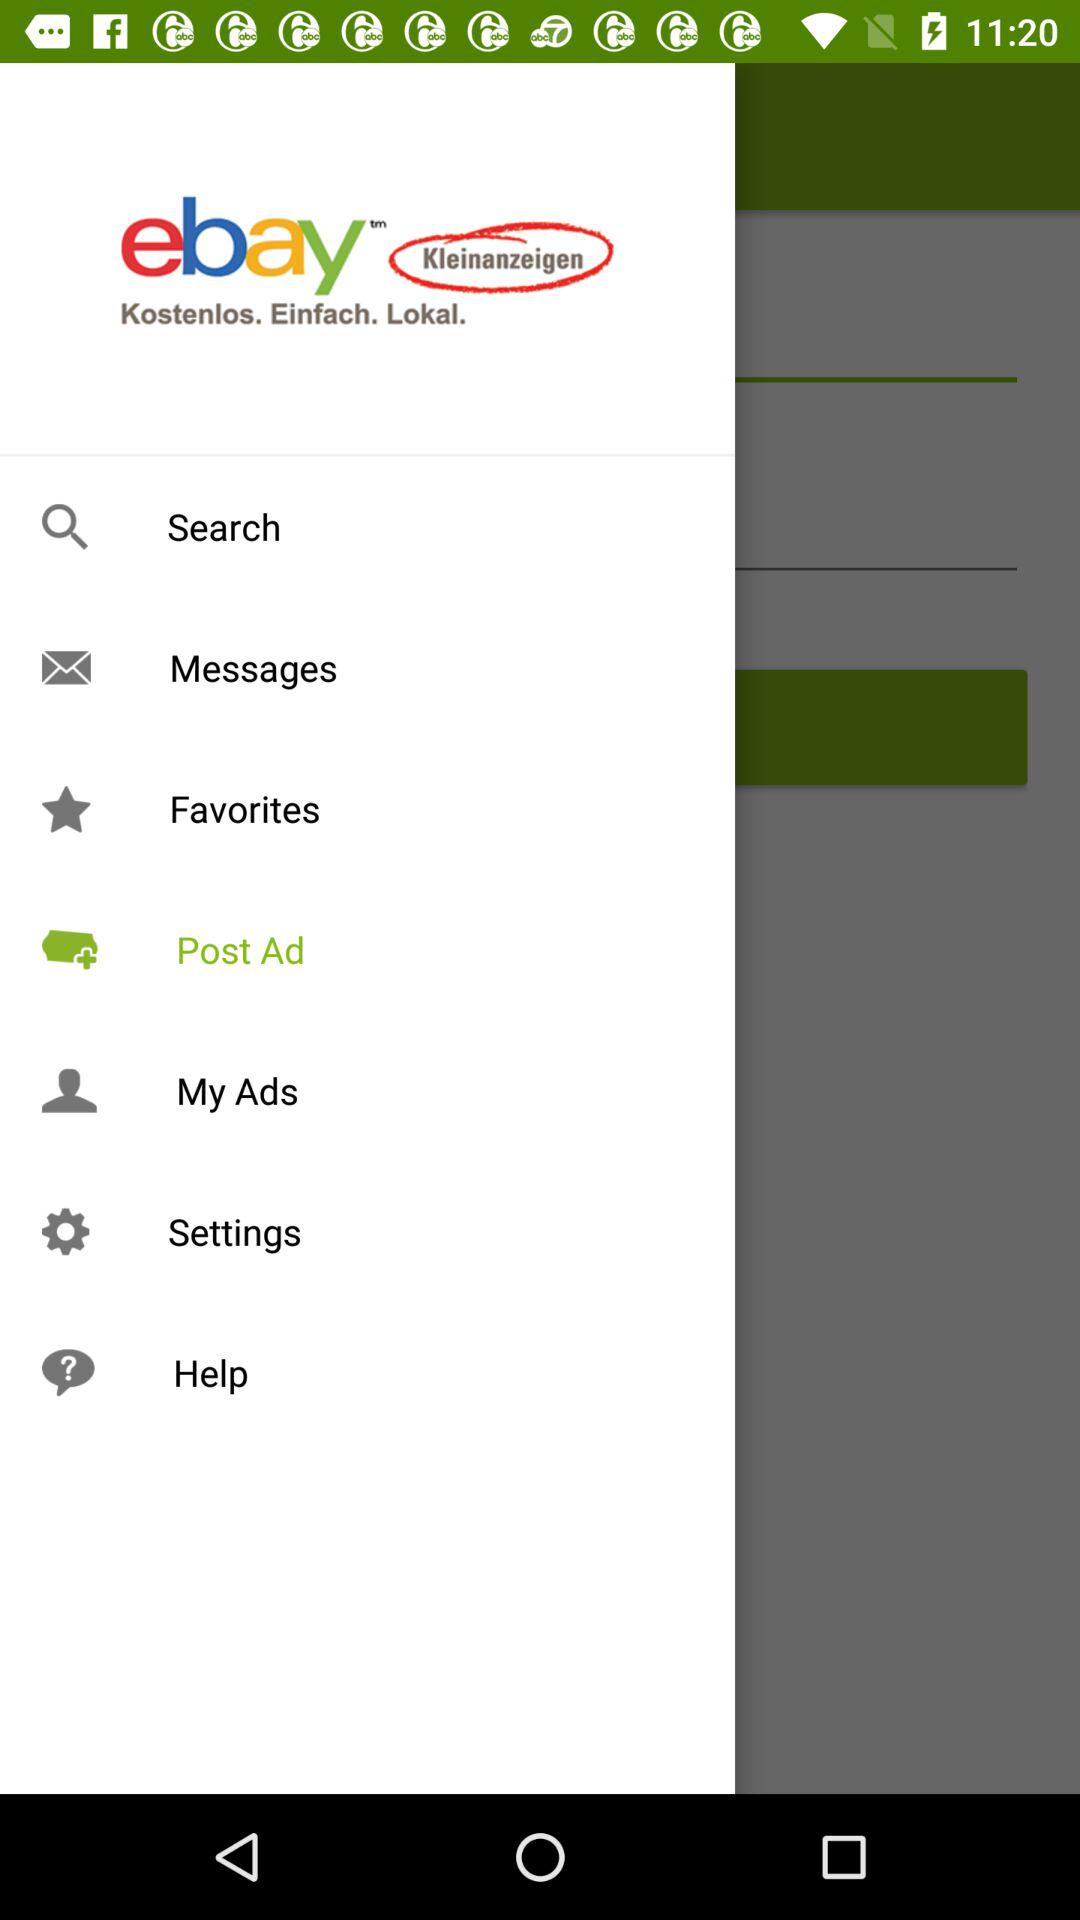What is the name of the application? The name of the application is "ebay". 